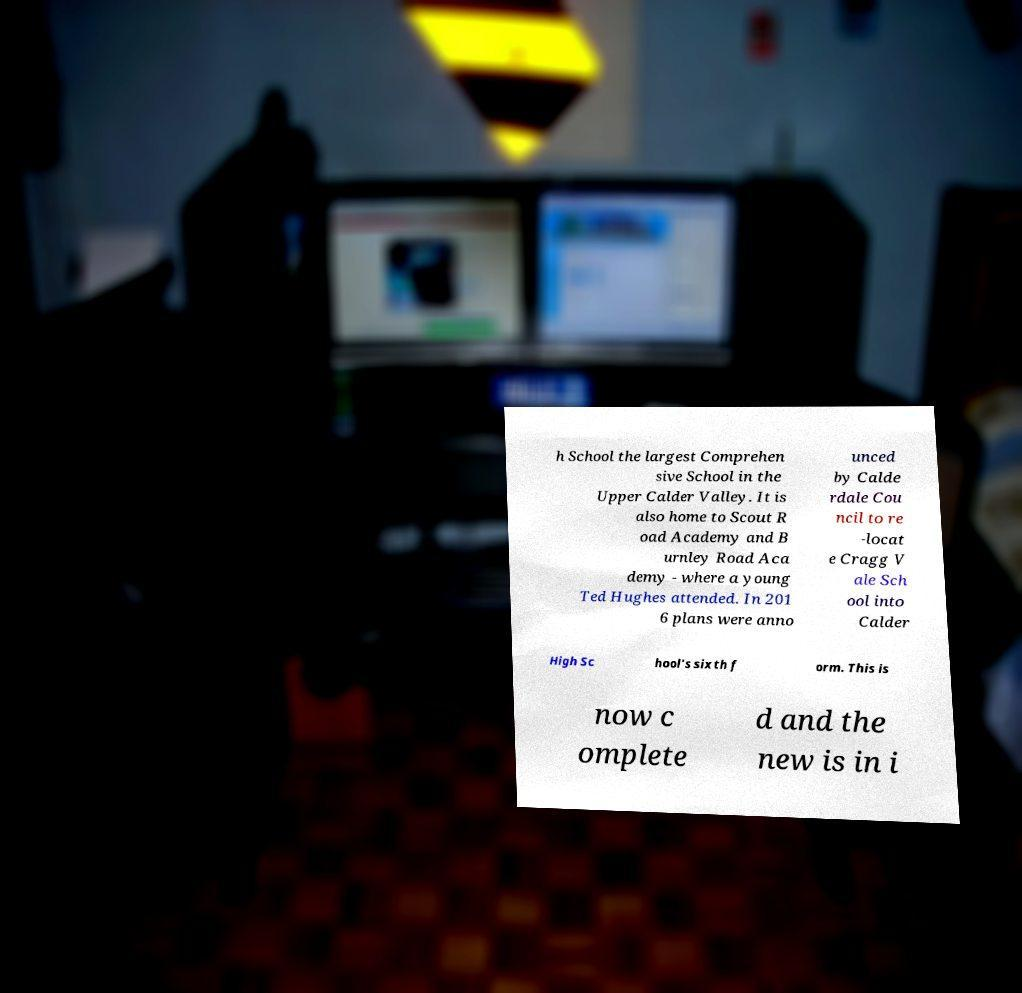Could you assist in decoding the text presented in this image and type it out clearly? h School the largest Comprehen sive School in the Upper Calder Valley. It is also home to Scout R oad Academy and B urnley Road Aca demy - where a young Ted Hughes attended. In 201 6 plans were anno unced by Calde rdale Cou ncil to re -locat e Cragg V ale Sch ool into Calder High Sc hool's sixth f orm. This is now c omplete d and the new is in i 